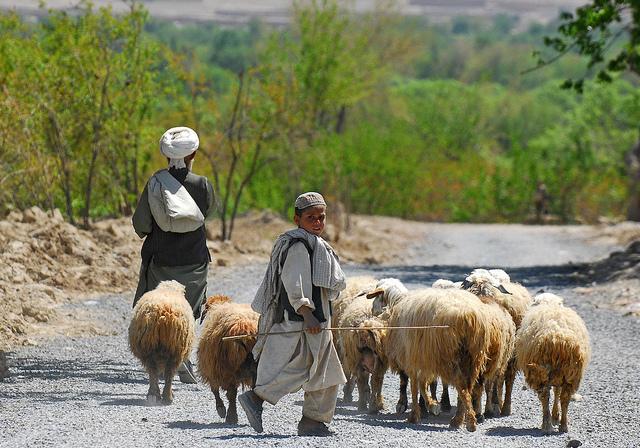What type of animal are these?
Answer briefly. Sheep. What substance is the ground made of?
Short answer required. Gravel. Are the animals herding the people?
Quick response, please. No. Is it cold outside?
Give a very brief answer. No. Are the sheep looking at the camera?
Keep it brief. No. 